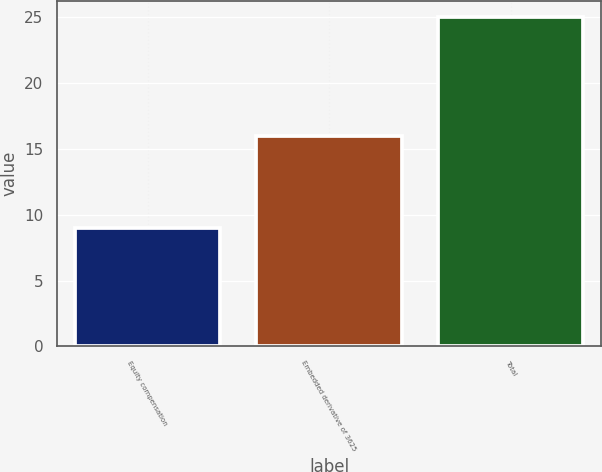<chart> <loc_0><loc_0><loc_500><loc_500><bar_chart><fcel>Equity compensation<fcel>Embedded derivative of 3625<fcel>Total<nl><fcel>9<fcel>16<fcel>25<nl></chart> 